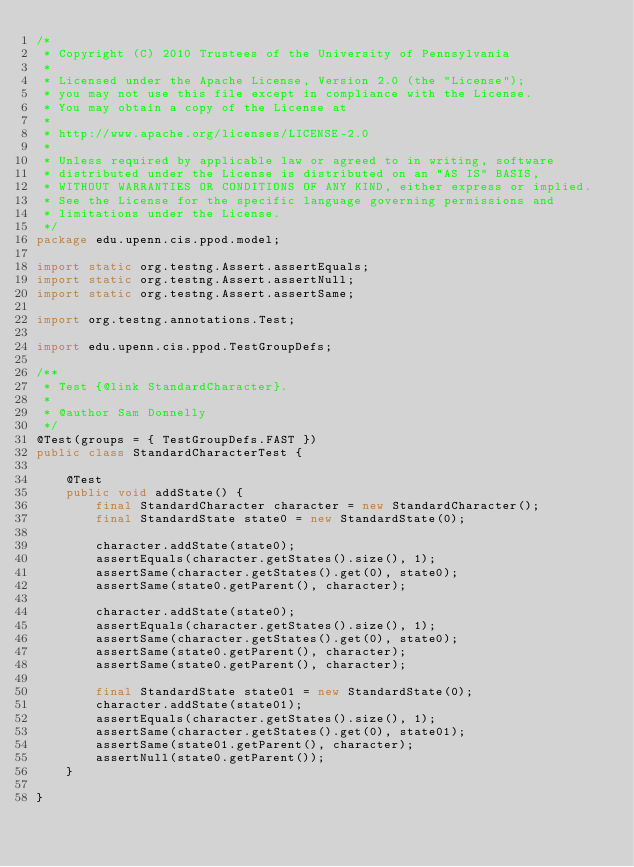Convert code to text. <code><loc_0><loc_0><loc_500><loc_500><_Java_>/*
 * Copyright (C) 2010 Trustees of the University of Pennsylvania
 *
 * Licensed under the Apache License, Version 2.0 (the "License");
 * you may not use this file except in compliance with the License.
 * You may obtain a copy of the License at
 *
 * http://www.apache.org/licenses/LICENSE-2.0
 *
 * Unless required by applicable law or agreed to in writing, software
 * distributed under the License is distributed on an "AS IS" BASIS,
 * WITHOUT WARRANTIES OR CONDITIONS OF ANY KIND, either express or implied.
 * See the License for the specific language governing permissions and
 * limitations under the License.
 */
package edu.upenn.cis.ppod.model;

import static org.testng.Assert.assertEquals;
import static org.testng.Assert.assertNull;
import static org.testng.Assert.assertSame;

import org.testng.annotations.Test;

import edu.upenn.cis.ppod.TestGroupDefs;

/**
 * Test {@link StandardCharacter}.
 * 
 * @author Sam Donnelly
 */
@Test(groups = { TestGroupDefs.FAST })
public class StandardCharacterTest {

	@Test
	public void addState() {
		final StandardCharacter character = new StandardCharacter();
		final StandardState state0 = new StandardState(0);

		character.addState(state0);
		assertEquals(character.getStates().size(), 1);
		assertSame(character.getStates().get(0), state0);
		assertSame(state0.getParent(), character);

		character.addState(state0);
		assertEquals(character.getStates().size(), 1);
		assertSame(character.getStates().get(0), state0);
		assertSame(state0.getParent(), character);
		assertSame(state0.getParent(), character);

		final StandardState state01 = new StandardState(0);
		character.addState(state01);
		assertEquals(character.getStates().size(), 1);
		assertSame(character.getStates().get(0), state01);
		assertSame(state01.getParent(), character);
		assertNull(state0.getParent());
	}

}
</code> 